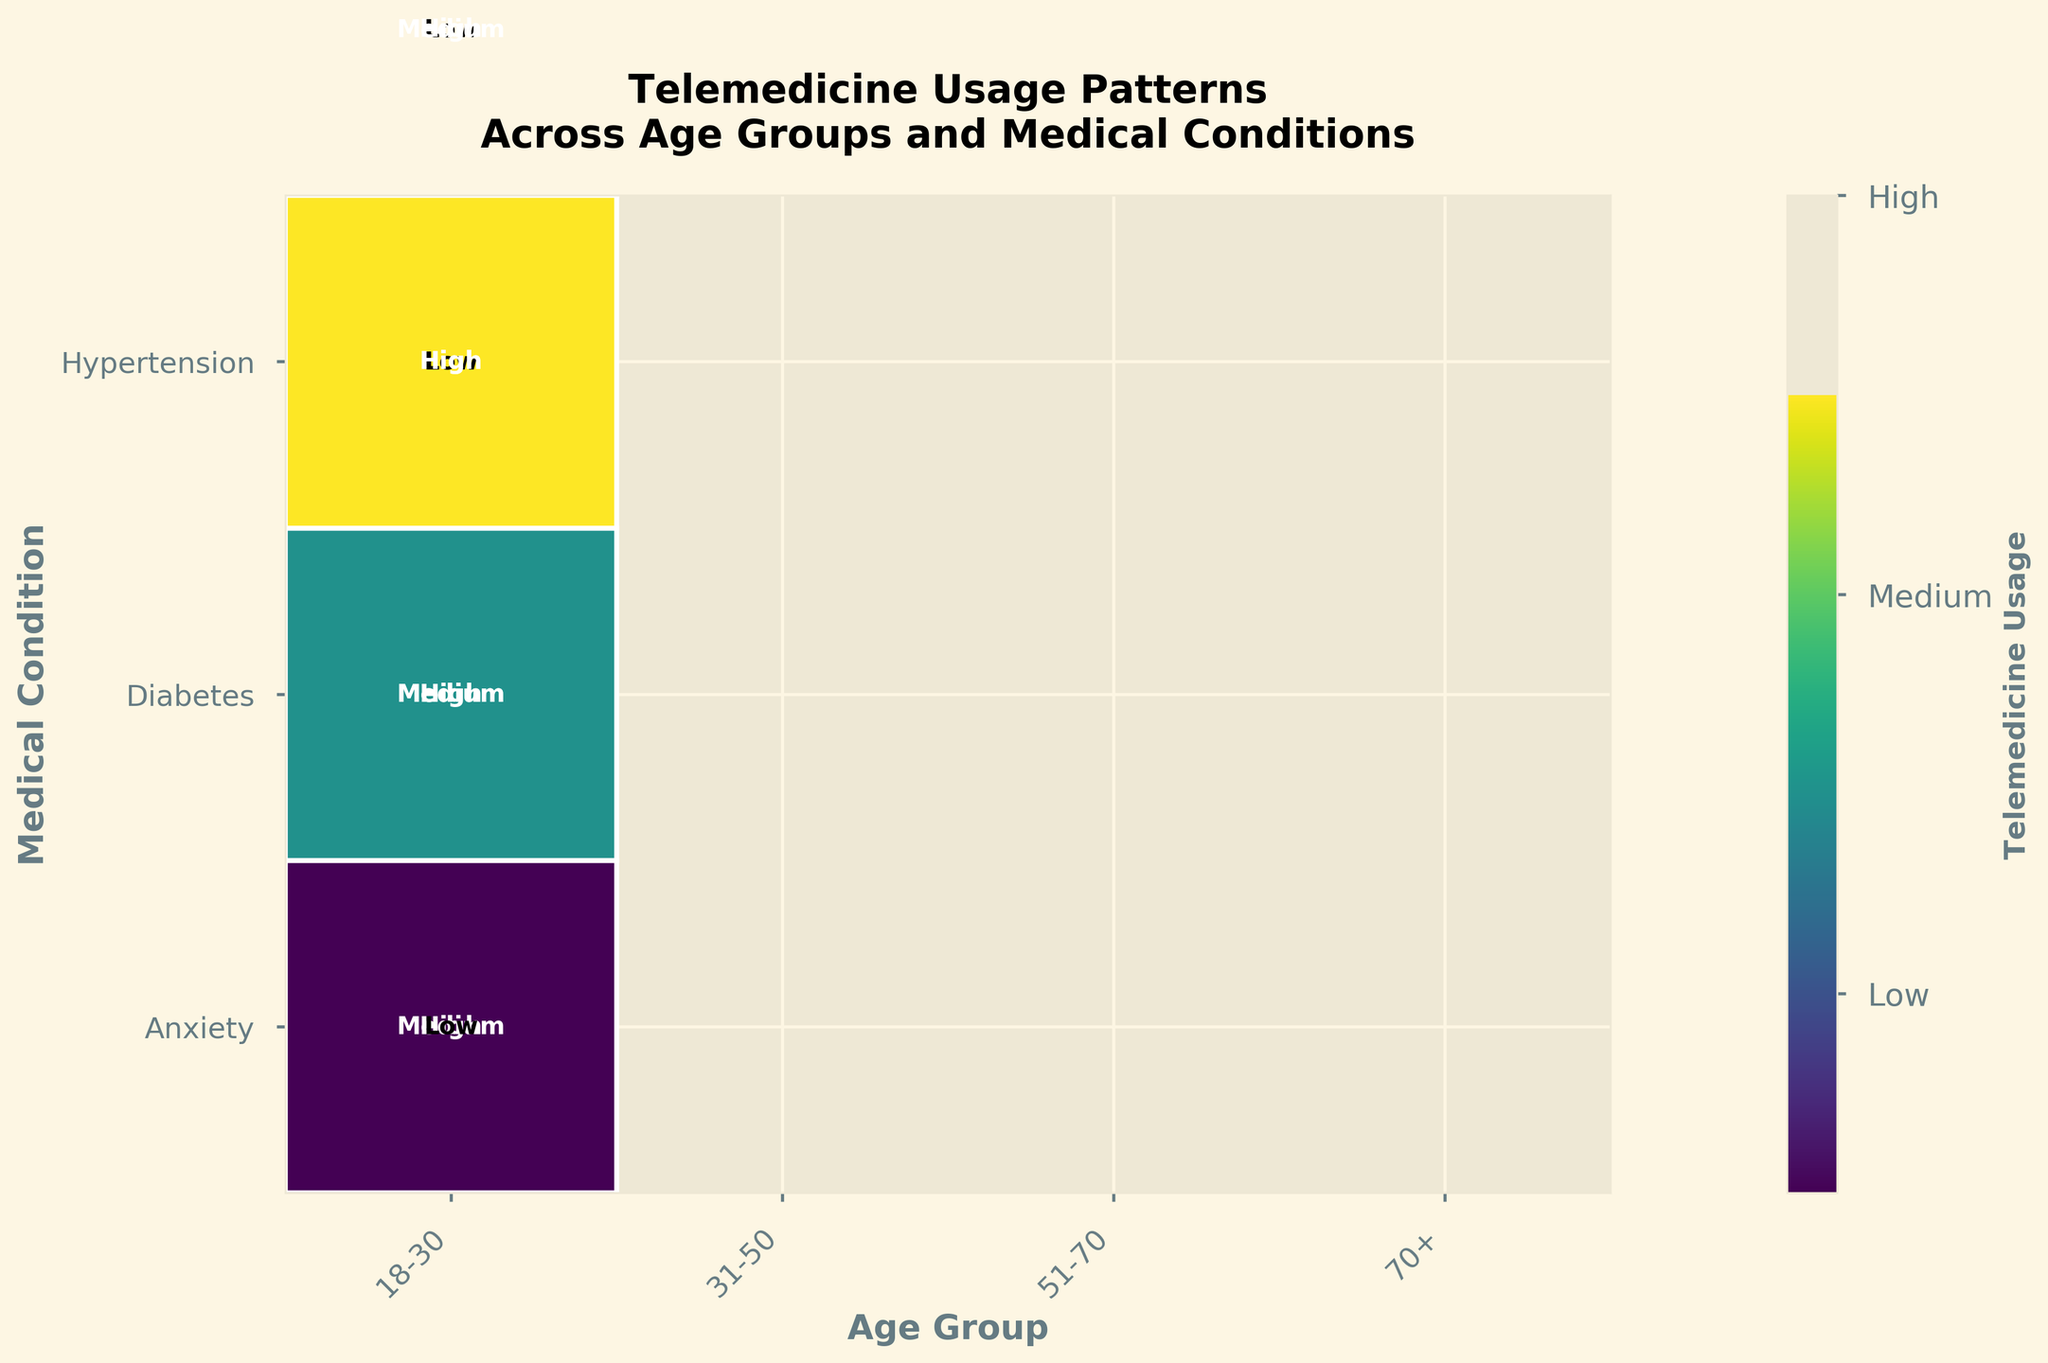What age group shows the highest telemedicine usage for Hypertension? Look at the telemedicine usage levels for Hypertension across all age groups. The highest usage level is "High," seen in age groups 51-70 and 70+.
Answer: 51-70 and 70+ Which medical condition has the least telemedicine usage for the 31-50 age group? For the 31-50 age group, compare the telemedicine usage levels across the three medical conditions. The condition with the "Low" usage level is Anxiety.
Answer: Anxiety Is telemedicine usage higher for Diabetes or Anxiety in the 18-30 age group? Compare the telemedicine usage levels for Diabetes and Anxiety within the 18-30 age group. Diabetes has a "Medium" usage level, while Anxiety has a "High" usage level.
Answer: Anxiety What is the overall telemedicine usage pattern for the 70+ age group? Observe the telemedicine usage levels for all medical conditions for the 70+ age group: Anxiety (Low), Diabetes (Medium), and Hypertension (High).
Answer: Low, Medium, High Compare the telemedicine usage for Hypertension between the 31-50 and 51-70 age groups. Analyze the telemedicine usage levels for Hypertension in both age groups. The 31-50 group has a "Medium" level, and the 51-70 group has a "High" level.
Answer: Higher in 51-70 Which age group shows consistent high telemedicine usage across multiple medical conditions? Look for age groups with "High" telemedicine usage in more than one medical condition. The 51-70 age group shows high usage for both Diabetes and Hypertension.
Answer: 51-70 Identify the condition with the highest telemedicine usage level across all age groups. Review the usage levels for the three conditions across all age groups. Hypertension has the most frequent "High" usage levels (51-70, 70+).
Answer: Hypertension Which age group has the most variation in telemedicine usage across different medical conditions? Check the usage levels for all conditions in each age group. The 70+ age group shows "Low," "Medium," and "High" usage levels for different conditions, indicating high variation.
Answer: 70+ 